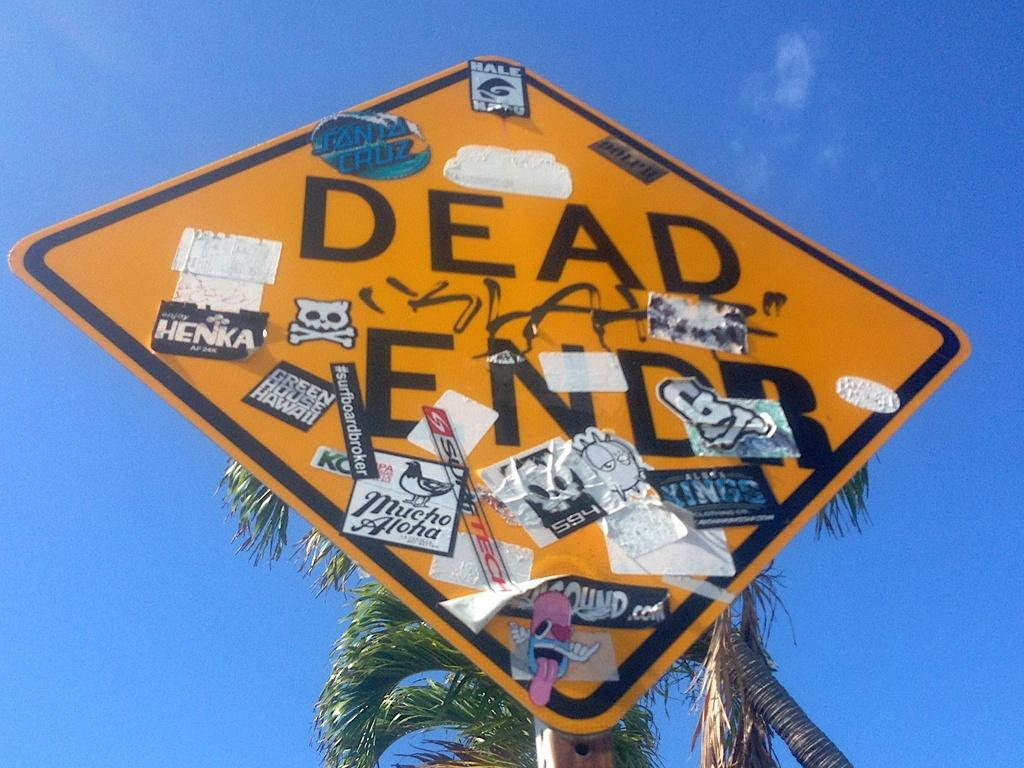Provide a one-sentence caption for the provided image. Green House Hawaii looks like one of the newest sticker placed on the sign. 